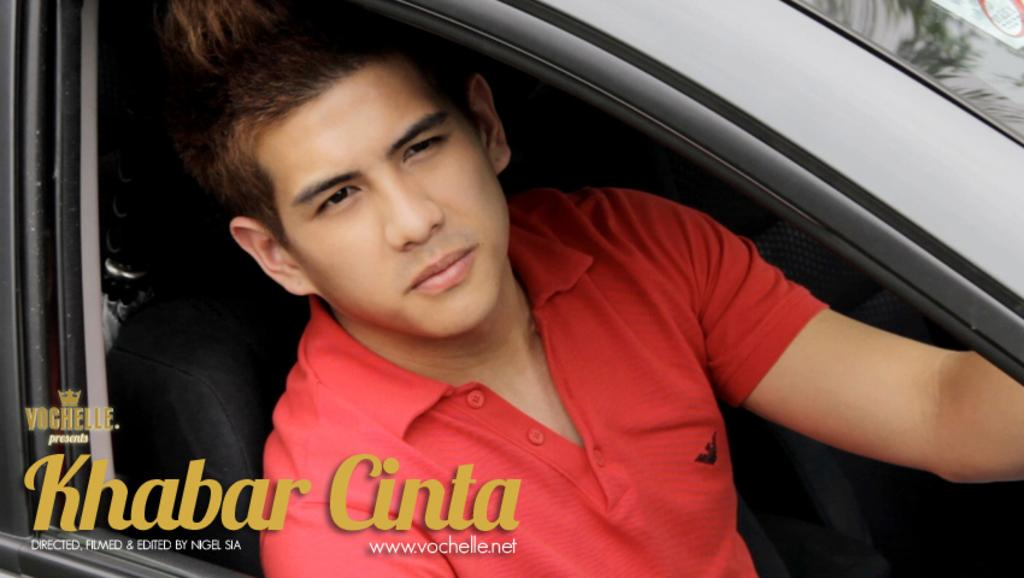What is the person in the image doing? The person is sitting inside the car. What color is the car seat? The car seat is black in color. What can be inferred about the color of the car? The car appears to be black. What color is the person's t-shirt? The person is wearing a red t-shirt. What type of control does the person have over the hammer in the image? There is no hammer present in the image. How many visitors can be seen in the image? There are no visitors present in the image. 